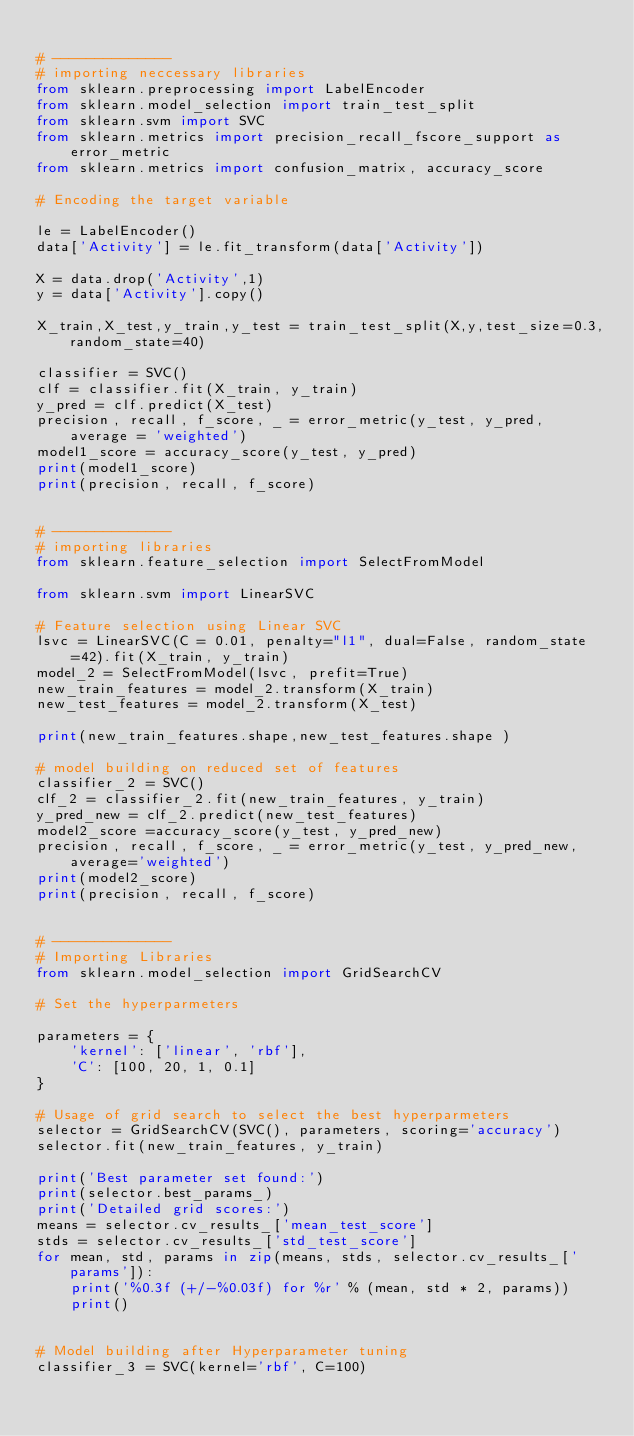<code> <loc_0><loc_0><loc_500><loc_500><_Python_>
# --------------
# importing neccessary libraries
from sklearn.preprocessing import LabelEncoder
from sklearn.model_selection import train_test_split
from sklearn.svm import SVC
from sklearn.metrics import precision_recall_fscore_support as error_metric
from sklearn.metrics import confusion_matrix, accuracy_score

# Encoding the target variable

le = LabelEncoder()
data['Activity'] = le.fit_transform(data['Activity'])

X = data.drop('Activity',1)
y = data['Activity'].copy()

X_train,X_test,y_train,y_test = train_test_split(X,y,test_size=0.3,random_state=40)

classifier = SVC()
clf = classifier.fit(X_train, y_train)
y_pred = clf.predict(X_test)
precision, recall, f_score, _ = error_metric(y_test, y_pred, average = 'weighted')
model1_score = accuracy_score(y_test, y_pred)
print(model1_score)
print(precision, recall, f_score)


# --------------
# importing libraries
from sklearn.feature_selection import SelectFromModel

from sklearn.svm import LinearSVC

# Feature selection using Linear SVC
lsvc = LinearSVC(C = 0.01, penalty="l1", dual=False, random_state=42).fit(X_train, y_train)
model_2 = SelectFromModel(lsvc, prefit=True)
new_train_features = model_2.transform(X_train)
new_test_features = model_2.transform(X_test)

print(new_train_features.shape,new_test_features.shape )

# model building on reduced set of features
classifier_2 = SVC()
clf_2 = classifier_2.fit(new_train_features, y_train)
y_pred_new = clf_2.predict(new_test_features)
model2_score =accuracy_score(y_test, y_pred_new)
precision, recall, f_score, _ = error_metric(y_test, y_pred_new, average='weighted')
print(model2_score)
print(precision, recall, f_score)


# --------------
# Importing Libraries
from sklearn.model_selection import GridSearchCV

# Set the hyperparmeters

parameters = {
    'kernel': ['linear', 'rbf'],
    'C': [100, 20, 1, 0.1]
}

# Usage of grid search to select the best hyperparmeters
selector = GridSearchCV(SVC(), parameters, scoring='accuracy') 
selector.fit(new_train_features, y_train)

print('Best parameter set found:')
print(selector.best_params_)
print('Detailed grid scores:')
means = selector.cv_results_['mean_test_score']
stds = selector.cv_results_['std_test_score']
for mean, std, params in zip(means, stds, selector.cv_results_['params']):
    print('%0.3f (+/-%0.03f) for %r' % (mean, std * 2, params))
    print()
    

# Model building after Hyperparameter tuning
classifier_3 = SVC(kernel='rbf', C=100)</code> 